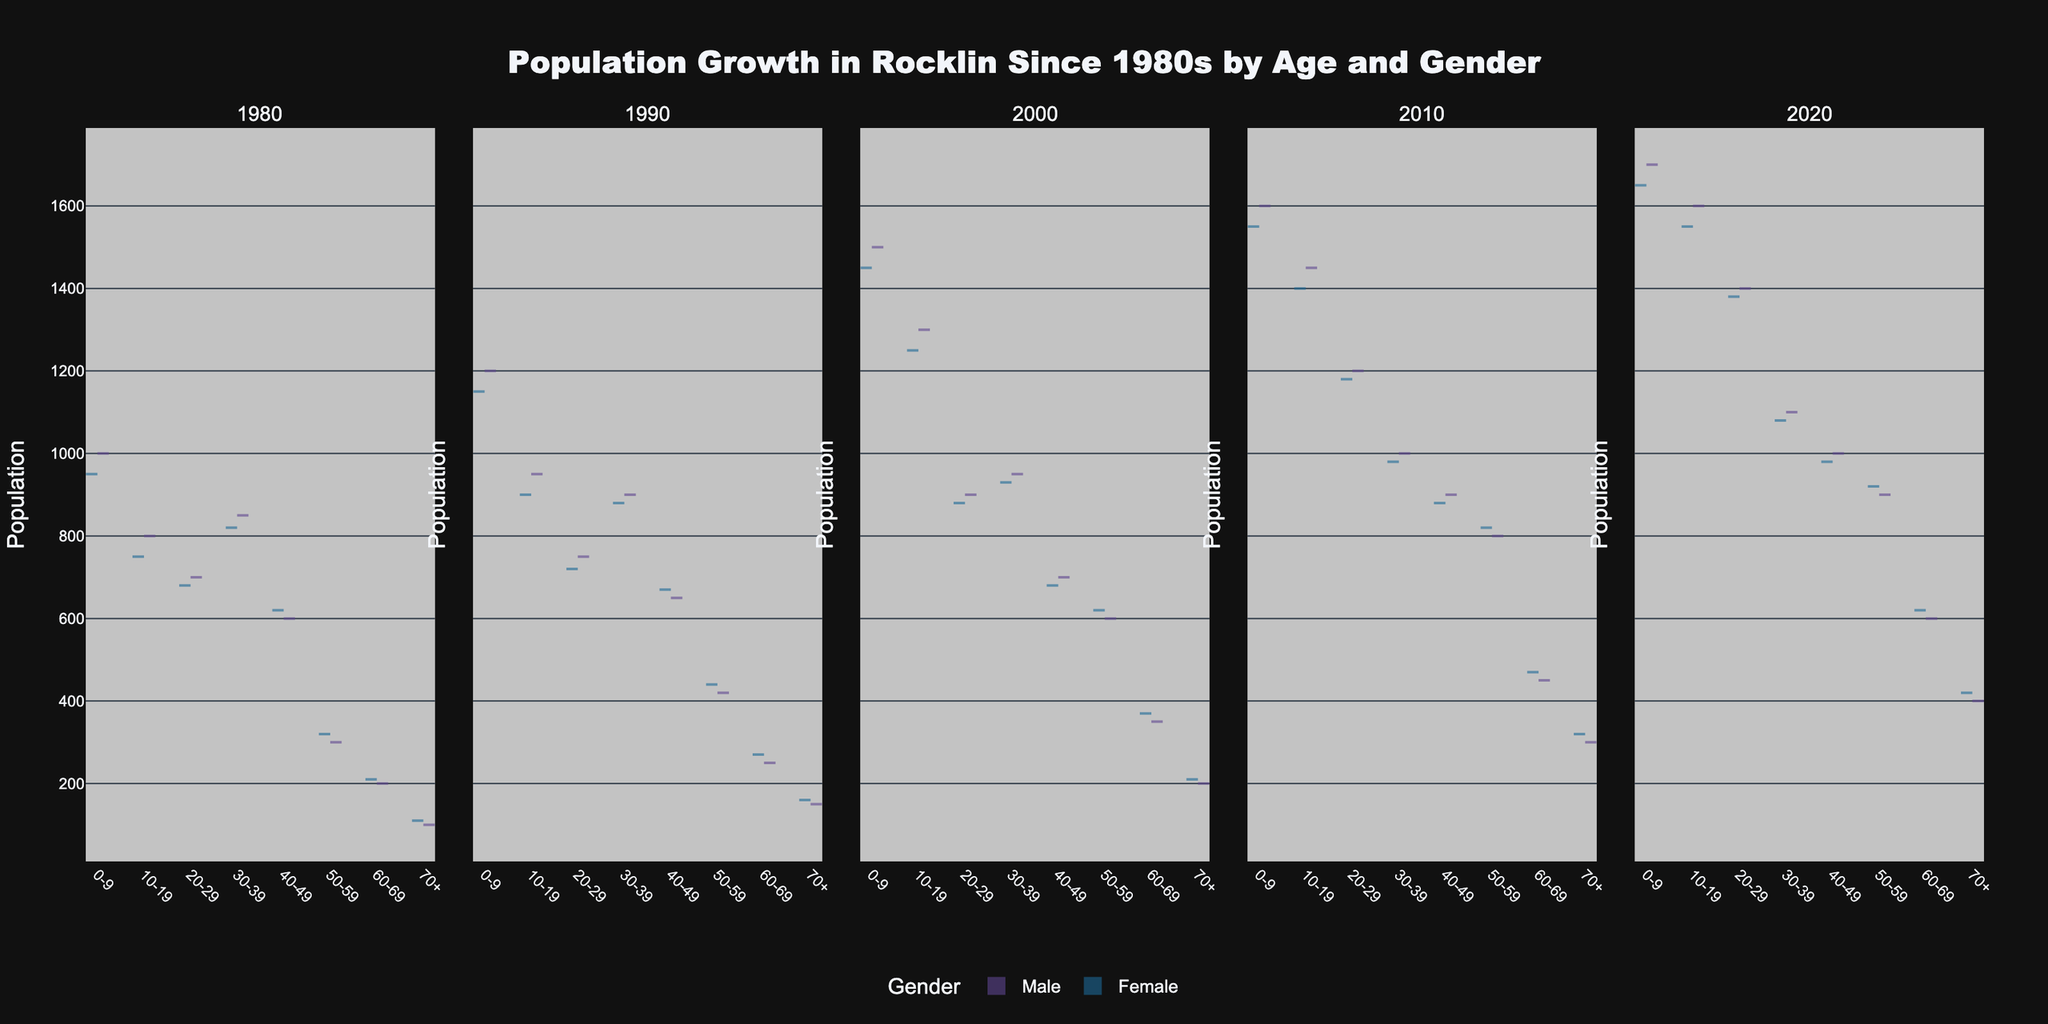What is the title of the figure? The figure's title is typically displayed at the top and is centered. For this figure, it reads "Population Growth in Rocklin Since 1980s by Age and Gender."
Answer: Population Growth in Rocklin Since 1980s by Age and Gender Which years are represented in the figure? The subplots represent different years. By reading the subplot titles, you can see the years 1980, 1990, 2000, 2010, and 2020.
Answer: 1980, 1990, 2000, 2010, 2020 In which year did the population of males aged 0-9 surpass 1500? By inspecting the relevant portions of each subplot for the age group 0-9 for males, the population surpasses 1500 in 2000.
Answer: 2000 Compare the male and female populations aged 10-19 in 2010. Which gender had a higher population? Look at the subplot for 2010, focusing on the age group 10-19. Compare the lengths of the violins for male and female sides. Males have a slightly higher population than females.
Answer: Male How many age groups are presented in each year? Each subplot shows multiple violin plots corresponding to age groups. By counting these, you can see there are seven age groups: 0-9, 10-19, 20-29, 30-39, 40-49, 50-59, 60-69, and 70+.
Answer: 7 What trend can be observed regarding the population of the 60-69 age group from 1980 to 2020? Examine each subplot from left to right for the 60-69 age group. The population consistently increases over time.
Answer: Increasing Are there more females or males aged 50-59 in 2020? Refer to the subplot for 2020. Observe the 50-59 age group. The length of the violin plot on the female side is longer than the male side, indicating more females.
Answer: Female Which year has the smallest population for the 70+ age group? Compare all subplots for the 70+ age group. The violin plot for 1980 is the shortest, indicating the smallest population.
Answer: 1980 What is the general shape of the violin plot for the male population aged 20-29 in 2010? Focus on the male portion of the violin plot for the age group 20-29 in 2010. The shape is more concentrated around a middle range, forming a bell shape.
Answer: Bell shape Calculate the total population of the 0-9 age group in 1990. The subplot for 1990 shows male and female populations for the 0-9 age group. Adding them up (1200 + 1150) gives a total of 2350.
Answer: 2350 